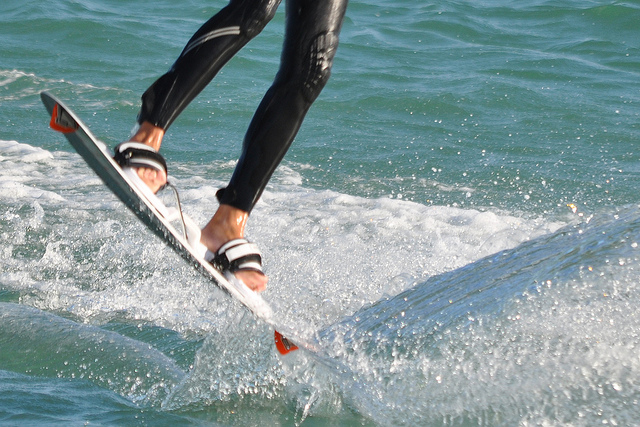What color is the water? The water appears to be a shade of turquoise, a color typically associated with clear tropical seas. 